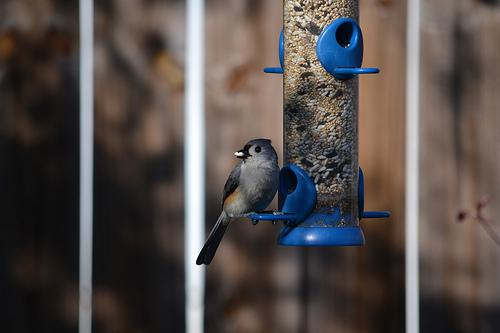Question: who is on the feeder?
Choices:
A. Eagle.
B. A bird.
C. Humming bird.
D. Robin.
Answer with the letter. Answer: B Question: where is the fence?
Choices:
A. Surrounding the house.
B. In the backyard.
C. Behind the feeder.
D. In the front yar.
Answer with the letter. Answer: C 